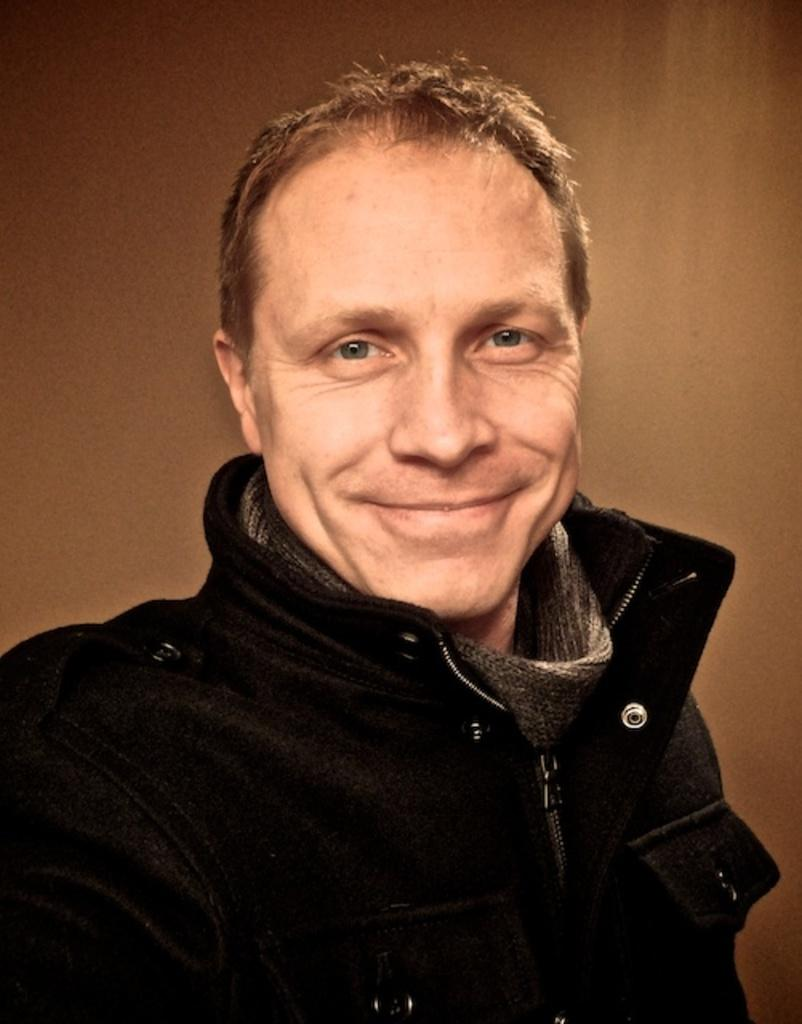Who is the main subject in the image? There is a man in the center of the image. What is the man doing in the image? The man is smiling. What can be seen behind the man in the image? There is a plain wall in the background of the image. What type of stone is the man holding in the image? There is no stone present in the image; the man is not holding anything. 